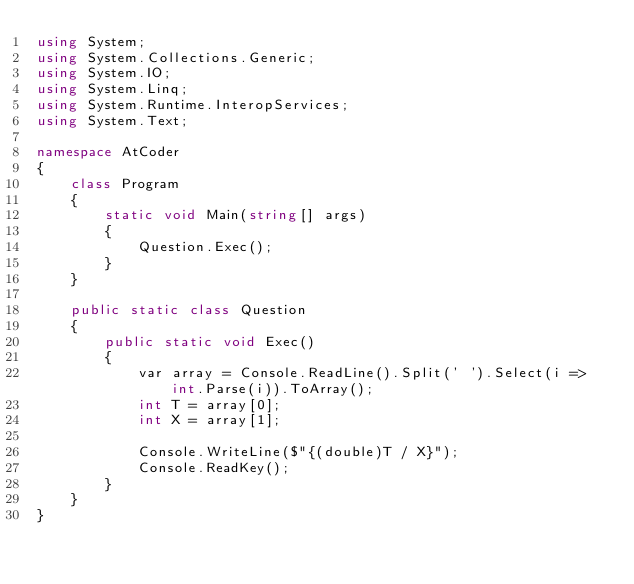Convert code to text. <code><loc_0><loc_0><loc_500><loc_500><_C#_>using System;
using System.Collections.Generic;
using System.IO;
using System.Linq;
using System.Runtime.InteropServices;
using System.Text;

namespace AtCoder
{
	class Program
	{
		static void Main(string[] args)
		{
			Question.Exec();
		}
	}

	public static class Question
	{
		public static void Exec()
		{
			var array = Console.ReadLine().Split(' ').Select(i => int.Parse(i)).ToArray();
			int T = array[0];
			int X = array[1];

			Console.WriteLine($"{(double)T / X}");
			Console.ReadKey();
		}
	}
}</code> 